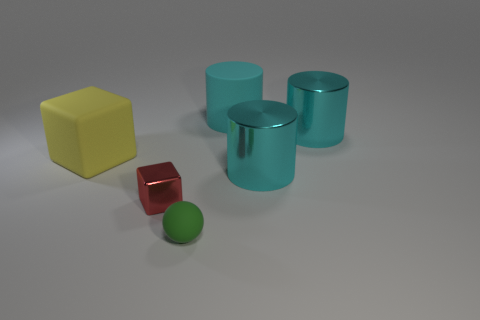Add 3 red objects. How many objects exist? 9 Subtract all spheres. How many objects are left? 5 Add 1 tiny red matte cylinders. How many tiny red matte cylinders exist? 1 Subtract 1 green spheres. How many objects are left? 5 Subtract all large metal objects. Subtract all big cyan metallic cylinders. How many objects are left? 2 Add 2 small green things. How many small green things are left? 3 